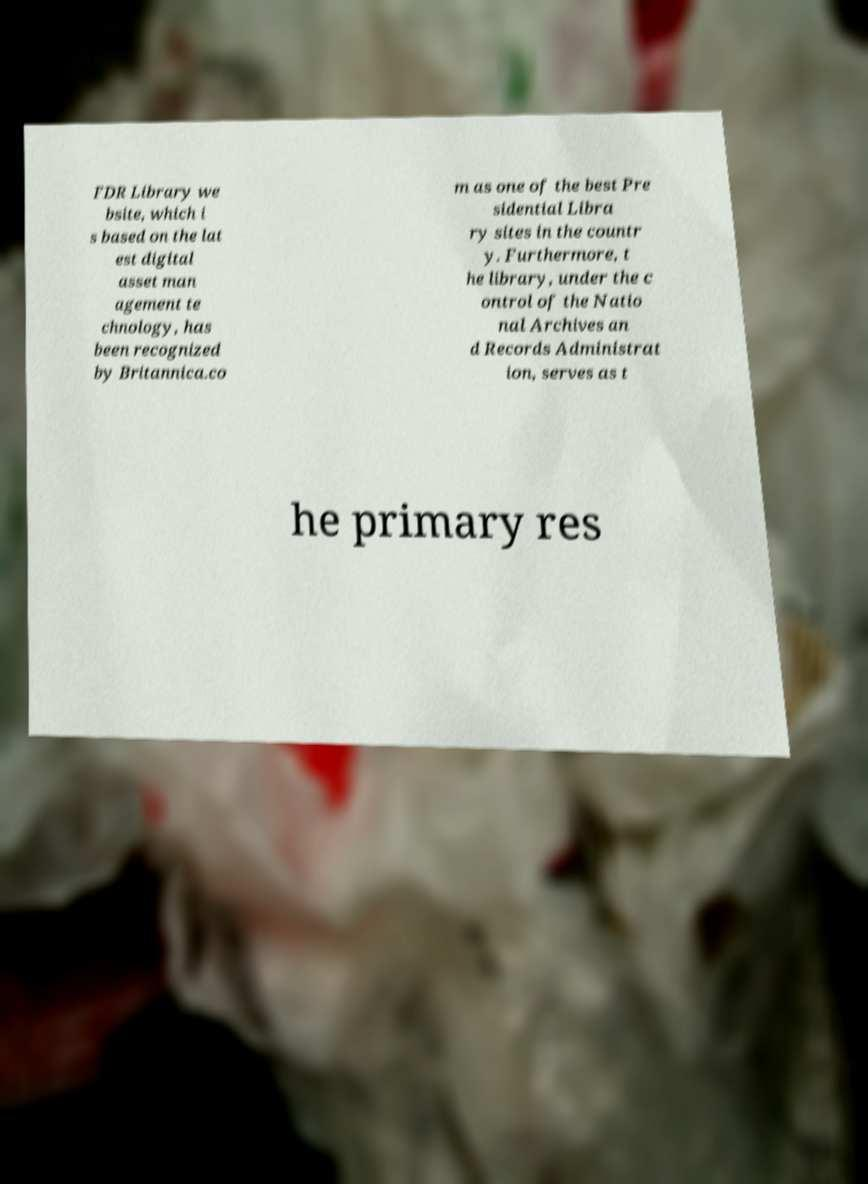Can you accurately transcribe the text from the provided image for me? FDR Library we bsite, which i s based on the lat est digital asset man agement te chnology, has been recognized by Britannica.co m as one of the best Pre sidential Libra ry sites in the countr y. Furthermore, t he library, under the c ontrol of the Natio nal Archives an d Records Administrat ion, serves as t he primary res 